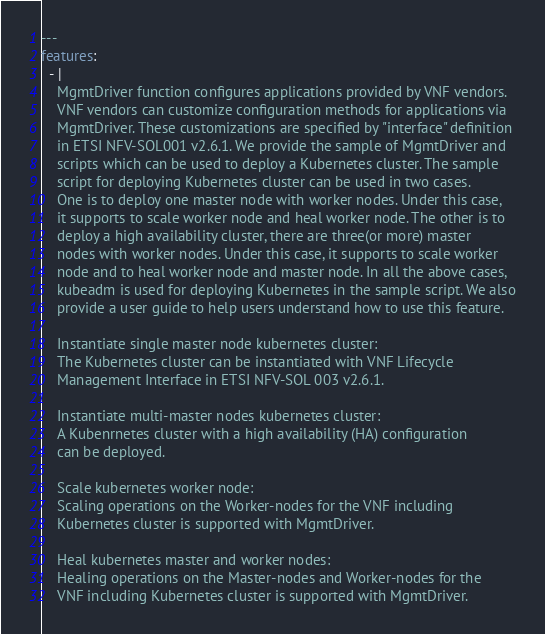<code> <loc_0><loc_0><loc_500><loc_500><_YAML_>---
features:
  - |
    MgmtDriver function configures applications provided by VNF vendors.
    VNF vendors can customize configuration methods for applications via
    MgmtDriver. These customizations are specified by "interface" definition
    in ETSI NFV-SOL001 v2.6.1. We provide the sample of MgmtDriver and
    scripts which can be used to deploy a Kubernetes cluster. The sample
    script for deploying Kubernetes cluster can be used in two cases.
    One is to deploy one master node with worker nodes. Under this case,
    it supports to scale worker node and heal worker node. The other is to
    deploy a high availability cluster, there are three(or more) master
    nodes with worker nodes. Under this case, it supports to scale worker
    node and to heal worker node and master node. In all the above cases,
    kubeadm is used for deploying Kubernetes in the sample script. We also
    provide a user guide to help users understand how to use this feature.

    Instantiate single master node kubernetes cluster:
    The Kubernetes cluster can be instantiated with VNF Lifecycle
    Management Interface in ETSI NFV-SOL 003 v2.6.1.

    Instantiate multi-master nodes kubernetes cluster:
    A Kubenrnetes cluster with a high availability (HA) configuration
    can be deployed.

    Scale kubernetes worker node:
    Scaling operations on the Worker-nodes for the VNF including
    Kubernetes cluster is supported with MgmtDriver.

    Heal kubernetes master and worker nodes:
    Healing operations on the Master-nodes and Worker-nodes for the
    VNF including Kubernetes cluster is supported with MgmtDriver.</code> 